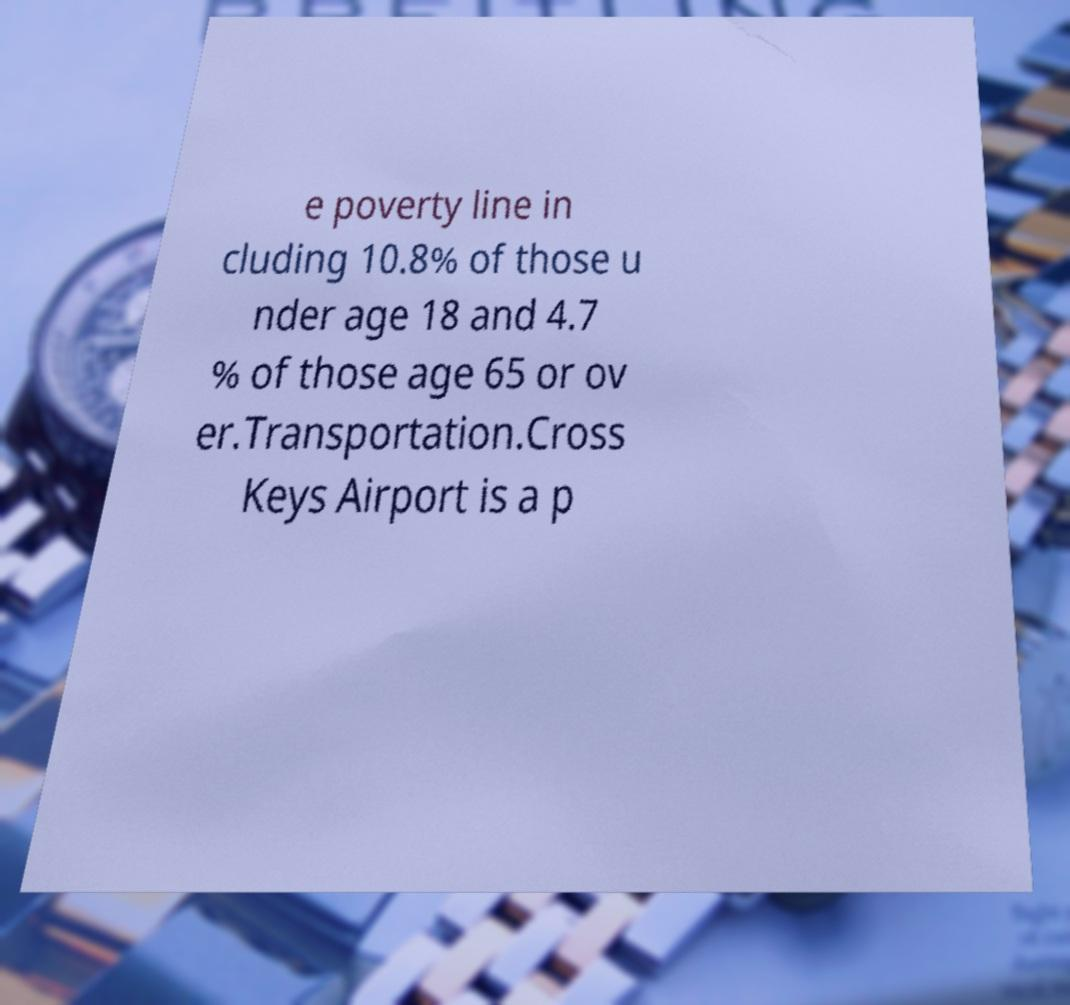There's text embedded in this image that I need extracted. Can you transcribe it verbatim? e poverty line in cluding 10.8% of those u nder age 18 and 4.7 % of those age 65 or ov er.Transportation.Cross Keys Airport is a p 